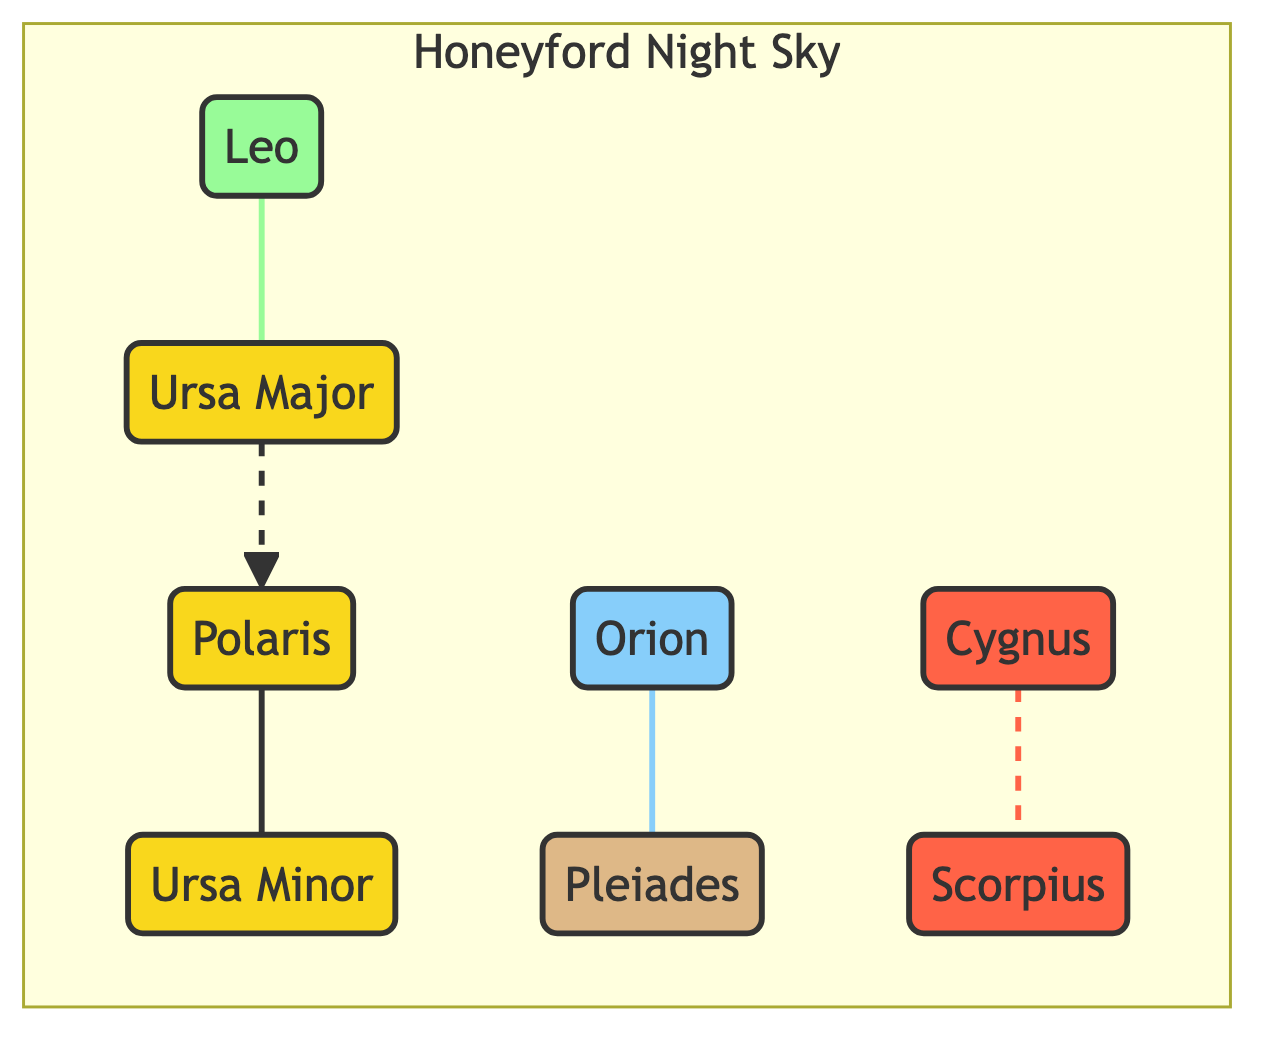What are the constellations visible year-round in the Honeyford night sky? The diagram lists Polaris, Ursa Major, and Ursa Minor as the constellations that are present throughout the year. This information can be found within the designated "yearRound" category, where these three constellations are marked.
Answer: Polaris, Ursa Major, Ursa Minor How many constellations are represented in the Honeyford night sky? By counting the nodes within the "Honeyford Night Sky" subgraph, we can see that there are a total of seven constellations: Polaris, Ursa Major, Ursa Minor, Orion, Scorpius, Cygnus, Pleaides, and Leo.
Answer: 7 Which constellation is associated with winter? The diagram indicates that Orion is categorized under the "winter" section. It is the only constellation marked with this seasonal classification.
Answer: Orion Which two constellations have a relationship in summer? According to the diagram, Scorpius and Cygnus are connected and marked as summer constellations. They are linked with a dashed line (indicating a connection), which signifies their relationship during the summer season.
Answer: Scorpius, Cygnus What relationship exists between Ursa Major and Polaris? The relationship represented is a directed dashed line from Ursa Major to Polaris, which indicates that Ursa Major is a guiding constellation related to Polaris, the North Star, primarily used for navigation.
Answer: Guiding relationship In what season is Leo visible? The diagram indicates that Leo is categorized under spring, making it visible during this transition from winter to summer. This can be directly inferred from the seasonal classification in the diagram.
Answer: Spring Which two constellations are directly connected to Orion? Orion has a direct connection to the constellation Pleiades, as indicated by the solid line drawn between them, showing a direct relationship, while there is no direct connection mentioned with any other constellation in this diagram.
Answer: Pleiades What color represents the autumn constellation in the diagram? The autumn constellation, Pleiades, is shown in a beige color (#deb887) according to the class assigned, which visually differentiates it from the other seasonal classifications.
Answer: Beige 